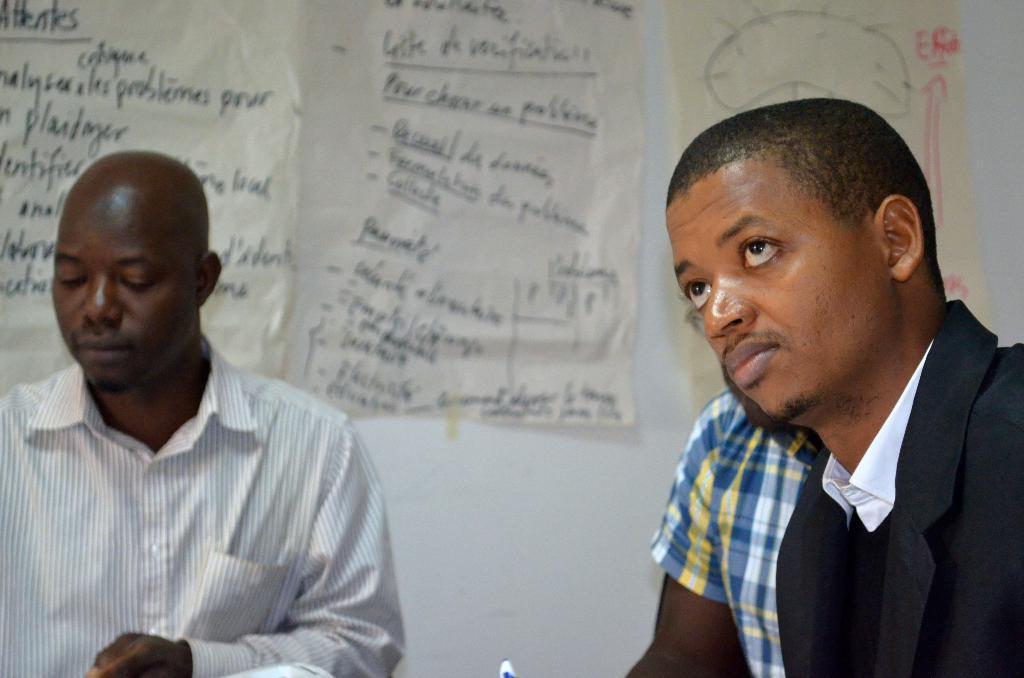Describe this image in one or two sentences. In this image I can see three person sitting. The person in front wearing black and white dress, and the person at back wearing white color dress, and I can see few papers attached to the wall and the wall is in white color. 